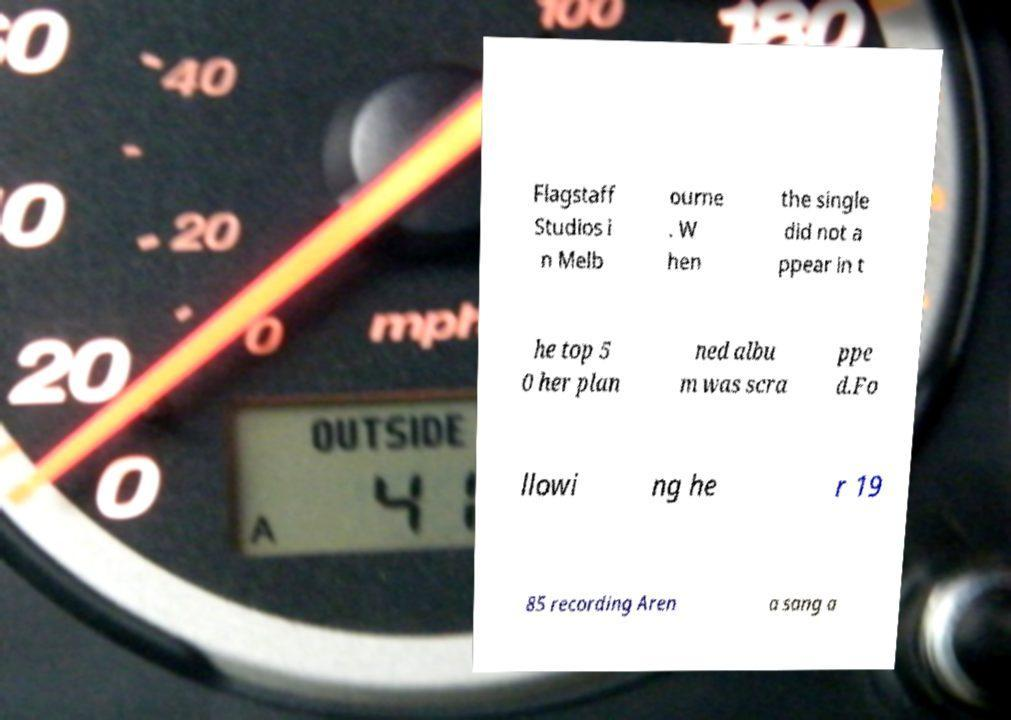There's text embedded in this image that I need extracted. Can you transcribe it verbatim? Flagstaff Studios i n Melb ourne . W hen the single did not a ppear in t he top 5 0 her plan ned albu m was scra ppe d.Fo llowi ng he r 19 85 recording Aren a sang a 